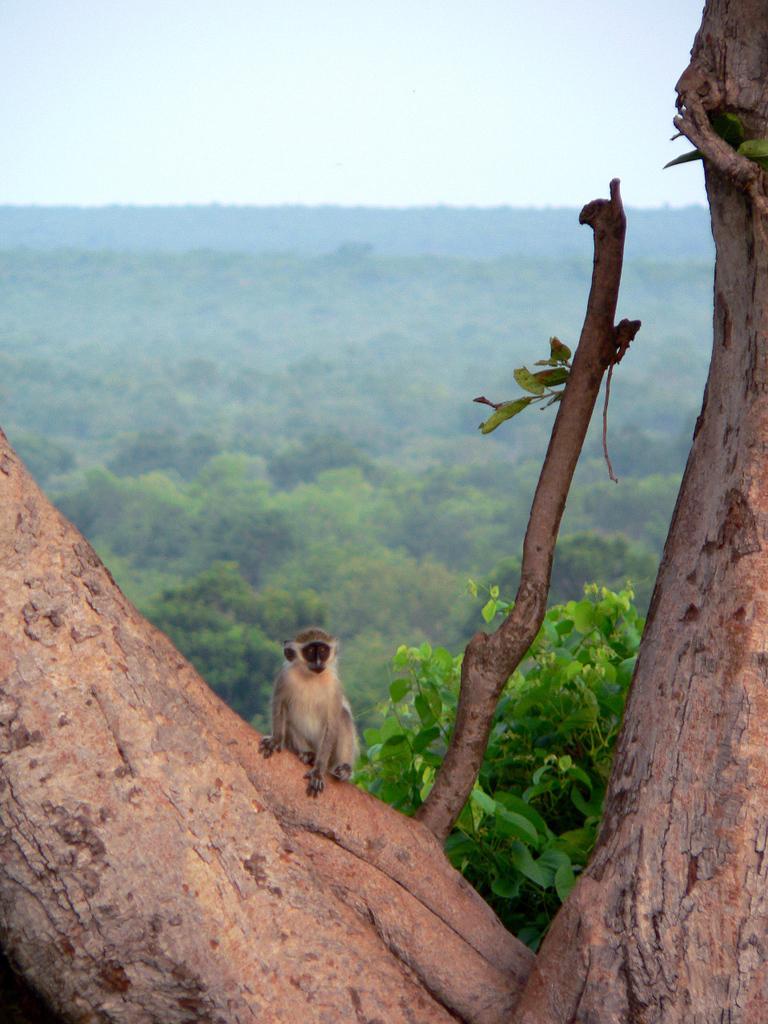Please provide a concise description of this image. In the center of the image we can see a monkey is present on a tree. In the background of the image we can see the trees. At the top of the image we can see the sky. 